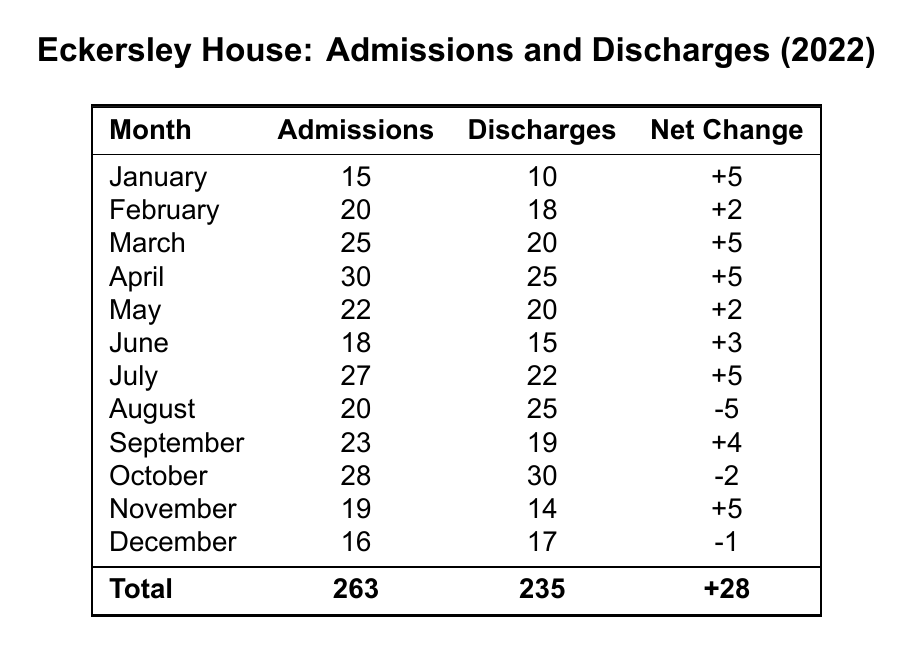What month had the highest number of admissions? In the table, the highest number of admissions is found in April, with 30 admissions.
Answer: April What is the total number of admissions and discharges for the year? To find the total, add all admissions (263) and discharges (235) together: 263 + 235 = 498.
Answer: 498 Which month had a negative net change? The months with negative net change are August, October, and December, as indicated by the minus sign in the Net Change column.
Answer: August, October, December How many more admissions were there than discharges in November? In November, there were 19 admissions and 14 discharges. The difference is 19 - 14 = 5.
Answer: 5 What is the average number of admissions per month? To calculate the average, divide the total admissions by the number of months: 263 admissions / 12 months = approximately 21.92, rounded to two decimal places.
Answer: 21.92 Did the number of discharges exceed the number of admissions in October? In October, there were 28 admissions and 30 discharges. Since 30 is greater than 28, the statement is true.
Answer: Yes What was the net change in admissions for the entire year? To find the net change for the year, we take total admissions (263) and total discharges (235), then calculate 263 - 235 = 28.
Answer: 28 Which month saw the highest number of discharges? October had the highest number of discharges at 30, according to the Discharges column.
Answer: October In which month was the net change the lowest? The month with the lowest net change was October, which had a net change of -2, as shown in the Net Change column.
Answer: October Can you list all the months where the net change was positive? The months with positive net change are January, February, March, April, May, June, July, September, and November, as they all have a + in the Net Change column.
Answer: January, February, March, April, May, June, July, September, November 